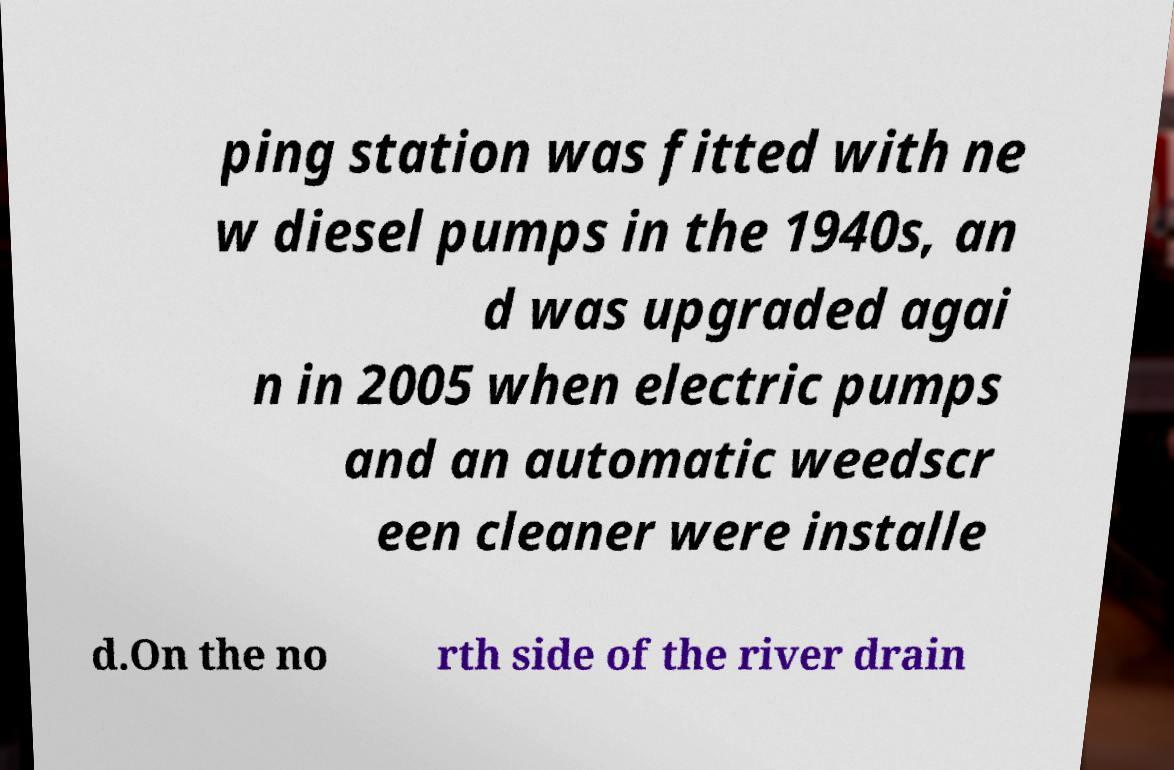I need the written content from this picture converted into text. Can you do that? ping station was fitted with ne w diesel pumps in the 1940s, an d was upgraded agai n in 2005 when electric pumps and an automatic weedscr een cleaner were installe d.On the no rth side of the river drain 